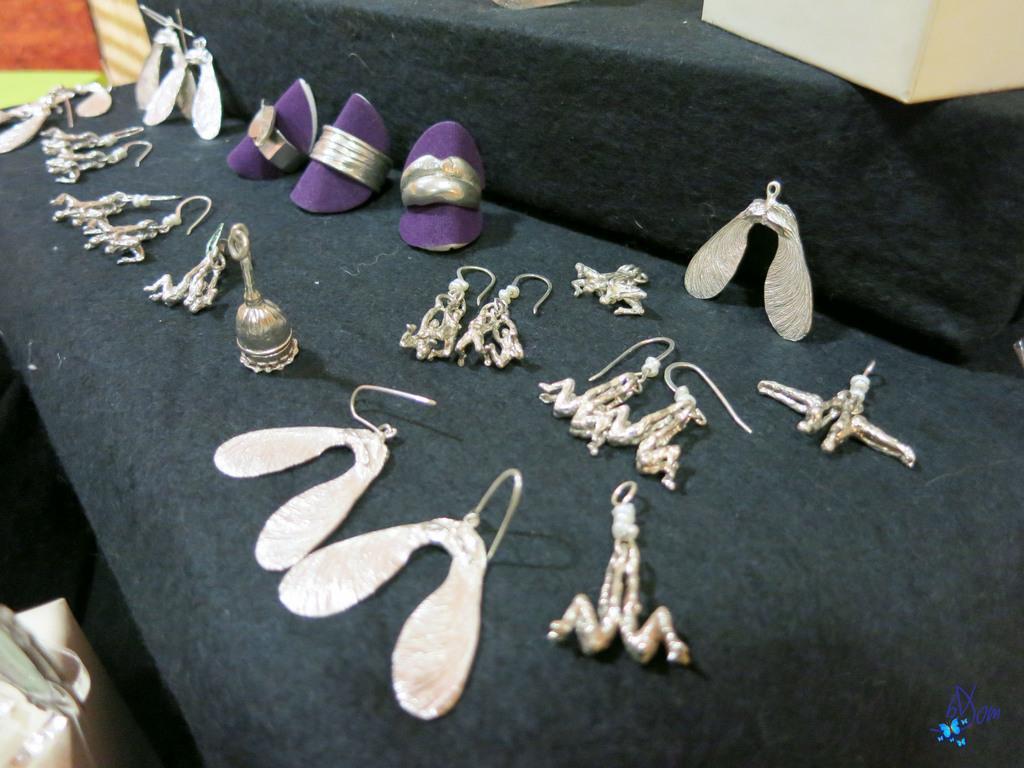Describe this image in one or two sentences. In this image, we can see few earrings, some objects, rings are placed on the black cloth. Top of the image, we can see a white box. At the bottom, we can see some object. Right side bottom of the image, we can see some icon 